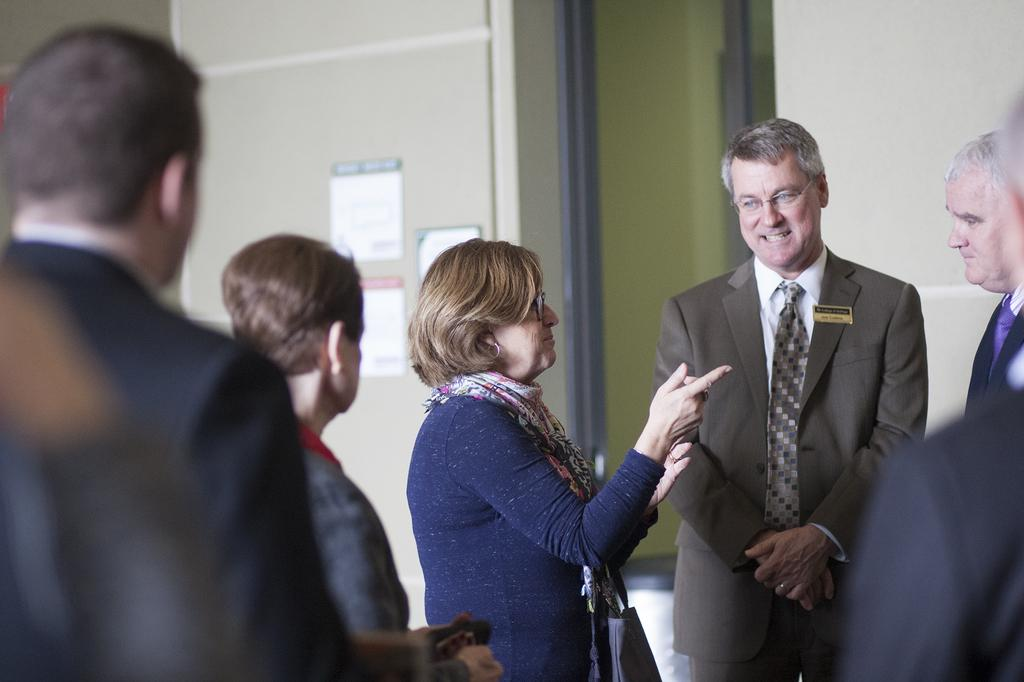What is happening in the image? There are people standing in the image. Can you describe what one of the people is holding? One person is carrying a bag. What can be seen in the background of the image? There is a building in the background of the image. What is on the building? There are posters on the building. Where is the shelf located in the image? There is no shelf present in the image. What type of needle can be seen in the image? There is no needle present in the image. 